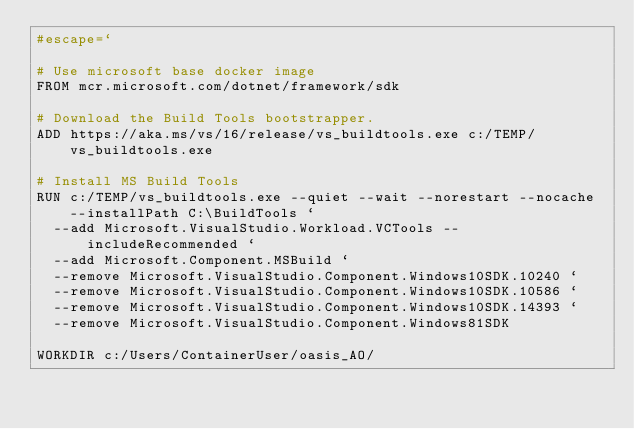<code> <loc_0><loc_0><loc_500><loc_500><_Dockerfile_>#escape=`

# Use microsoft base docker image
FROM mcr.microsoft.com/dotnet/framework/sdk

# Download the Build Tools bootstrapper.
ADD https://aka.ms/vs/16/release/vs_buildtools.exe c:/TEMP/vs_buildtools.exe

# Install MS Build Tools
RUN c:/TEMP/vs_buildtools.exe --quiet --wait --norestart --nocache --installPath C:\BuildTools `
  --add Microsoft.VisualStudio.Workload.VCTools --includeRecommended `
  --add Microsoft.Component.MSBuild `
  --remove Microsoft.VisualStudio.Component.Windows10SDK.10240 `
  --remove Microsoft.VisualStudio.Component.Windows10SDK.10586 `
  --remove Microsoft.VisualStudio.Component.Windows10SDK.14393 `
  --remove Microsoft.VisualStudio.Component.Windows81SDK

WORKDIR c:/Users/ContainerUser/oasis_AO/</code> 